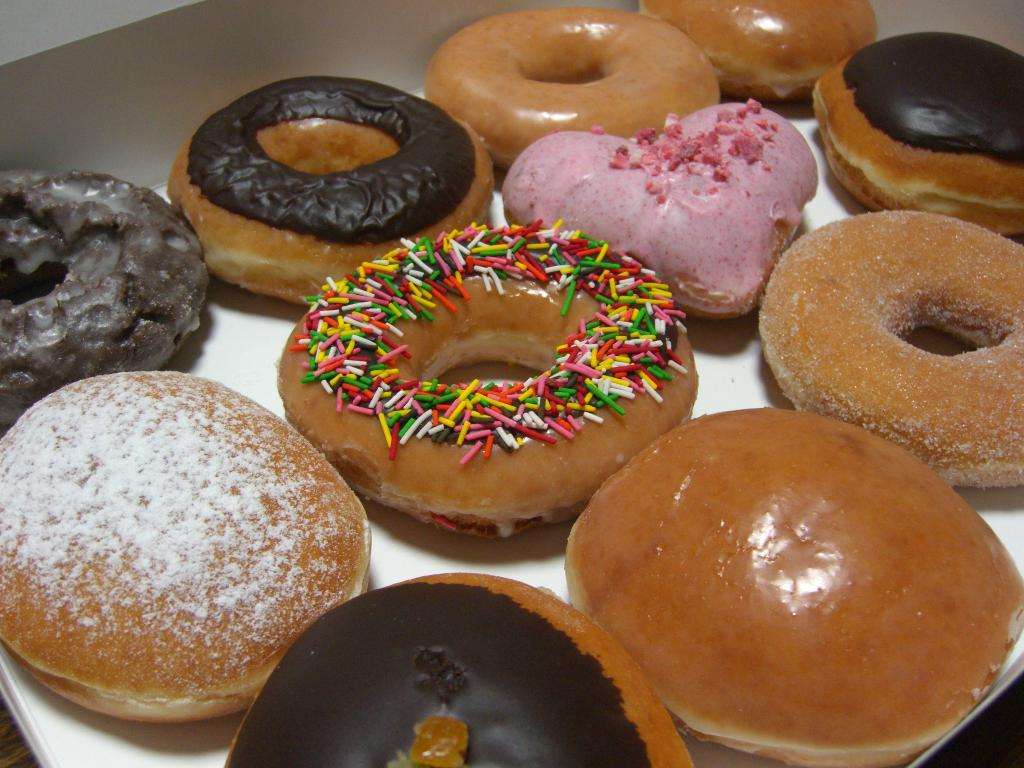What type of food is visible on the white surface in the image? There are doughnuts on a white surface in the image. What type of cheese is visible on the white surface in the image? There is no cheese present in the image; it is a white surface with doughnuts on it. What tendency can be observed in the doughnuts in the image? There is no specific tendency observable in the doughnuts in the image, as they are simply doughnuts on a white surface. Can you see any beetles crawling on the doughnuts in the image? There are no beetles present in the image; it features doughnuts on a white surface. 